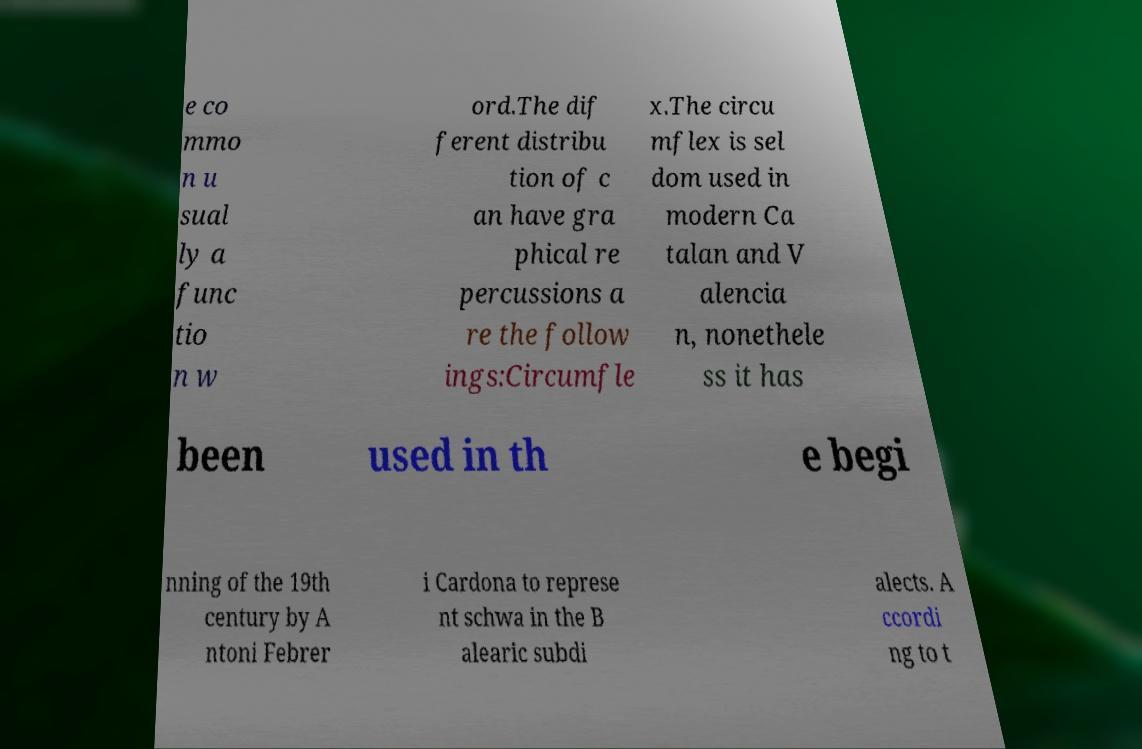Please read and relay the text visible in this image. What does it say? e co mmo n u sual ly a func tio n w ord.The dif ferent distribu tion of c an have gra phical re percussions a re the follow ings:Circumfle x.The circu mflex is sel dom used in modern Ca talan and V alencia n, nonethele ss it has been used in th e begi nning of the 19th century by A ntoni Febrer i Cardona to represe nt schwa in the B alearic subdi alects. A ccordi ng to t 